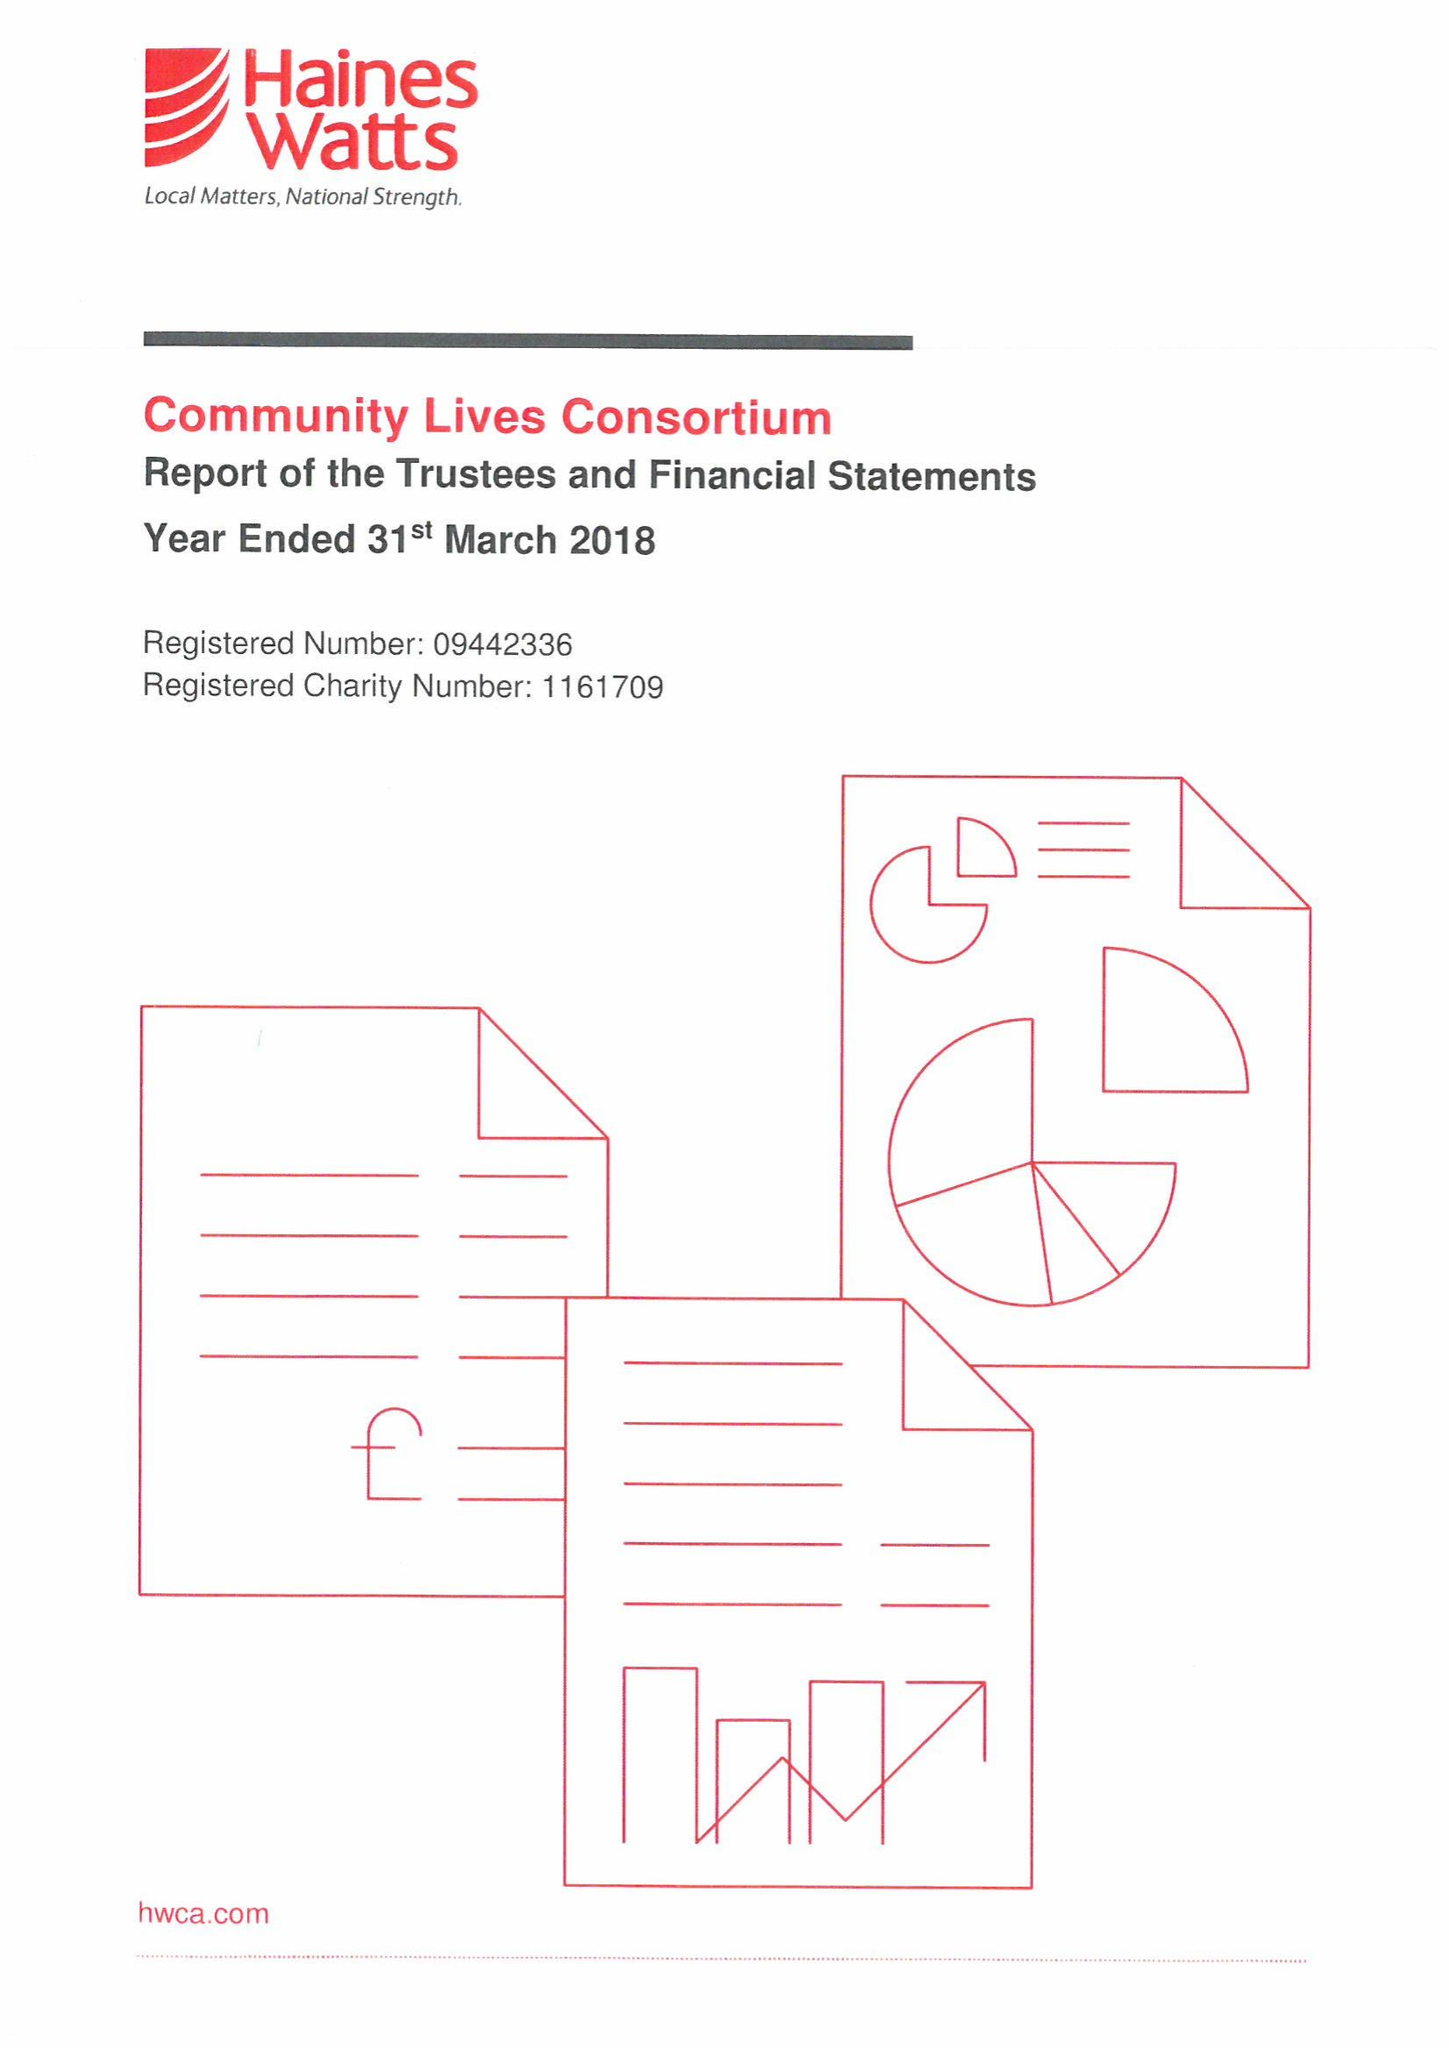What is the value for the address__street_line?
Answer the question using a single word or phrase. 24 WALTER ROAD 